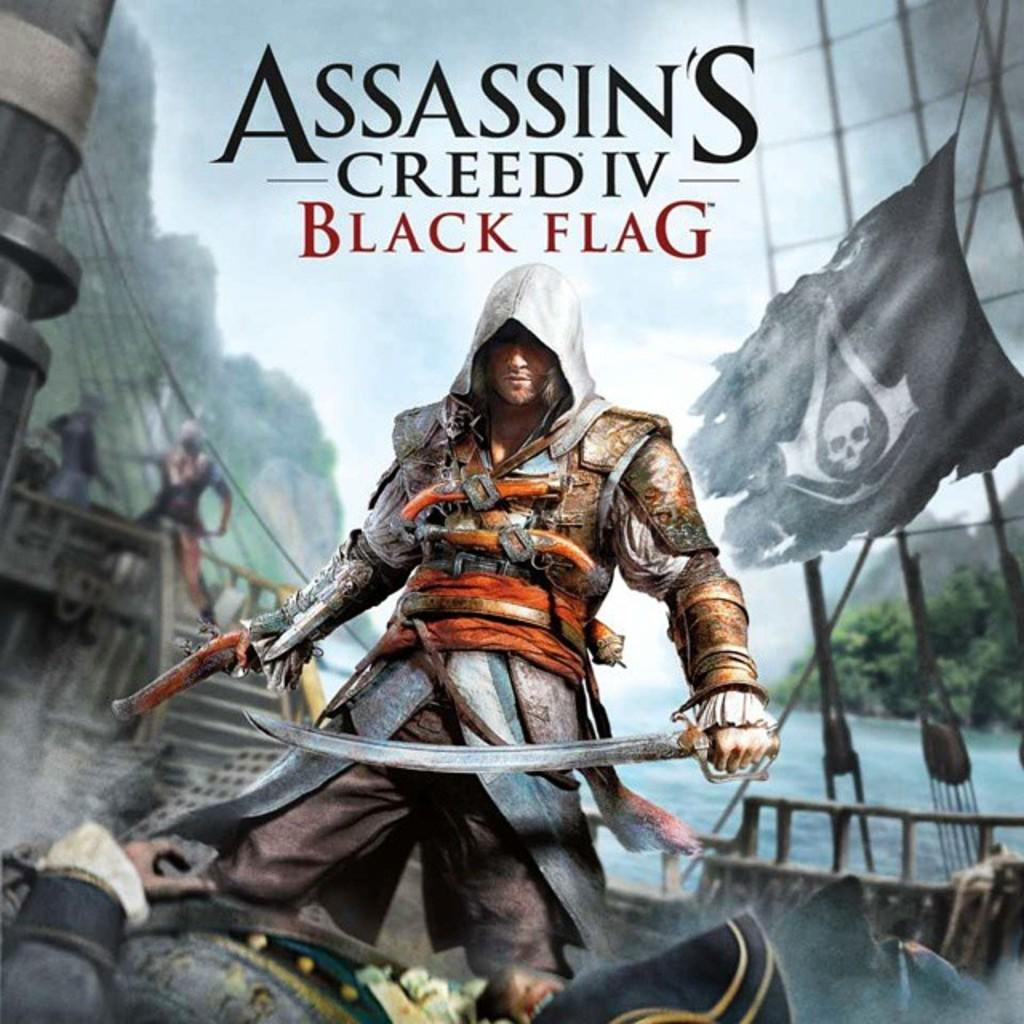<image>
Share a concise interpretation of the image provided. The artwork for Assassin's Creed Black Flag features a black pirate flag. 